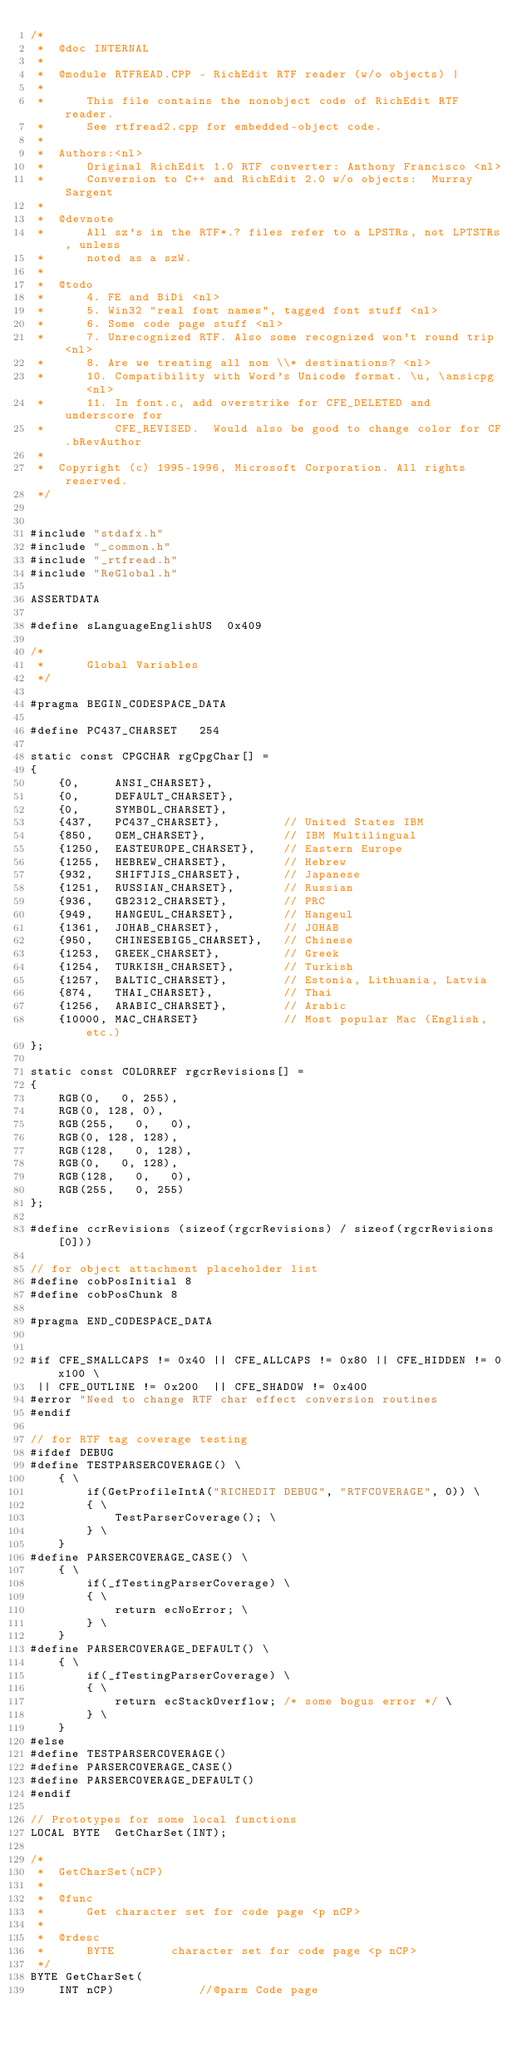Convert code to text. <code><loc_0><loc_0><loc_500><loc_500><_C++_>/*
 *	@doc INTERNAL
 *
 *	@module	RTFREAD.CPP - RichEdit RTF reader (w/o objects) |
 *
 *		This file contains the nonobject code of RichEdit RTF reader.
 *		See rtfread2.cpp for embedded-object code.
 *
 *	Authors:<nl>
 *		Original RichEdit 1.0 RTF converter: Anthony Francisco <nl>
 *		Conversion to C++ and RichEdit 2.0 w/o objects:  Murray Sargent
 *
 *	@devnote
 *		All sz's in the RTF*.? files refer to a LPSTRs, not LPTSTRs, unless
 *		noted as a szW.
 *
 *	@todo
 *		4. FE and BiDi <nl>
 *		5. Win32 "real font names", tagged font stuff <nl>
 *		6. Some code page stuff <nl>
 *		7. Unrecognized RTF. Also some recognized won't round trip <nl>
 *		8. Are we treating all non \\* destinations? <nl>
 *		10. Compatibility with Word's Unicode format. \u, \ansicpg	 <nl>
 *		11. In font.c, add overstrike for CFE_DELETED and underscore for
 *			CFE_REVISED.  Would also be good to change color for CF.bRevAuthor
 *
 *	Copyright (c) 1995-1996, Microsoft Corporation. All rights reserved.
 */


#include "stdafx.h"
#include "_common.h"
#include "_rtfread.h"
#include "ReGlobal.h"

ASSERTDATA

#define sLanguageEnglishUS	0x409

/*
 *		Global Variables
 */

#pragma BEGIN_CODESPACE_DATA

#define	PC437_CHARSET	254

static const CPGCHAR rgCpgChar[] =
{
	{0,		ANSI_CHARSET},
	{0,		DEFAULT_CHARSET},
	{0,		SYMBOL_CHARSET},
	{437,	PC437_CHARSET},			// United States IBM
	{850,	OEM_CHARSET},			// IBM Multilingual
	{1250,	EASTEUROPE_CHARSET},	// Eastern Europe
	{1255,	HEBREW_CHARSET},		// Hebrew
	{932,	SHIFTJIS_CHARSET},		// Japanese
	{1251,	RUSSIAN_CHARSET},		// Russian
	{936,	GB2312_CHARSET},		// PRC
	{949,	HANGEUL_CHARSET},		// Hangeul
	{1361,	JOHAB_CHARSET},			// JOHAB
	{950,	CHINESEBIG5_CHARSET},	// Chinese
	{1253,	GREEK_CHARSET},			// Greek
	{1254,	TURKISH_CHARSET},		// Turkish
	{1257,	BALTIC_CHARSET},		// Estonia, Lithuania, Latvia
	{874,	THAI_CHARSET},			// Thai
	{1256,  ARABIC_CHARSET},		// Arabic
	{10000,	MAC_CHARSET}			// Most popular Mac (English, etc.)
};

static const COLORREF rgcrRevisions[] =
{
	RGB(0,   0, 255),
	RGB(0, 128,	0),
	RGB(255,   0, 	0),
	RGB(0, 128, 128),
	RGB(128,   0, 128),
	RGB(0,   0, 128),
	RGB(128,   0, 	0),
	RGB(255,   0, 255)
};

#define ccrRevisions (sizeof(rgcrRevisions) / sizeof(rgcrRevisions[0]))

// for object attachment placeholder list
#define cobPosInitial 8
#define cobPosChunk 8

#pragma END_CODESPACE_DATA


#if CFE_SMALLCAPS != 0x40 || CFE_ALLCAPS != 0x80 || CFE_HIDDEN != 0x100 \
 || CFE_OUTLINE != 0x200  || CFE_SHADOW != 0x400
#error "Need to change RTF char effect conversion routines
#endif

// for RTF tag coverage testing
#ifdef DEBUG
#define TESTPARSERCOVERAGE() \
	{ \
		if(GetProfileIntA("RICHEDIT DEBUG", "RTFCOVERAGE", 0)) \
		{ \
			TestParserCoverage(); \
		} \
	}
#define PARSERCOVERAGE_CASE() \
	{ \
		if(_fTestingParserCoverage) \
		{ \
			return ecNoError; \
		} \
	}
#define PARSERCOVERAGE_DEFAULT() \
	{ \
		if(_fTestingParserCoverage) \
		{ \
			return ecStackOverflow; /* some bogus error */ \
		} \
	}
#else
#define TESTPARSERCOVERAGE()
#define PARSERCOVERAGE_CASE()
#define PARSERCOVERAGE_DEFAULT()
#endif

// Prototypes for some local functions
LOCAL BYTE	GetCharSet(INT);

/*
 *	GetCharSet(nCP)
 *
 *	@func
 *		Get character set for code page <p nCP>
 *
 *	@rdesc
 *		BYTE		character set for code page <p nCP>
 */
BYTE GetCharSet(
	INT nCP)			//@parm Code page</code> 